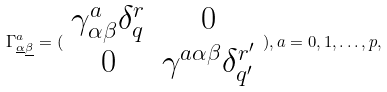<formula> <loc_0><loc_0><loc_500><loc_500>\Gamma _ { \underline { \alpha } \underline { \beta } } ^ { a } = ( \begin{array} { c c } \gamma _ { \alpha \beta } ^ { a } \delta _ { q } ^ { r } & 0 \\ 0 & \gamma ^ { a \alpha \beta } \delta _ { q ^ { \prime } } ^ { r ^ { \prime } } \end{array} ) , a = 0 , 1 , \dots , p ,</formula> 